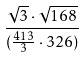<formula> <loc_0><loc_0><loc_500><loc_500>\frac { \sqrt { 3 } \cdot \sqrt { 1 6 8 } } { ( \frac { 4 1 3 } { 3 } \cdot 3 2 6 ) }</formula> 